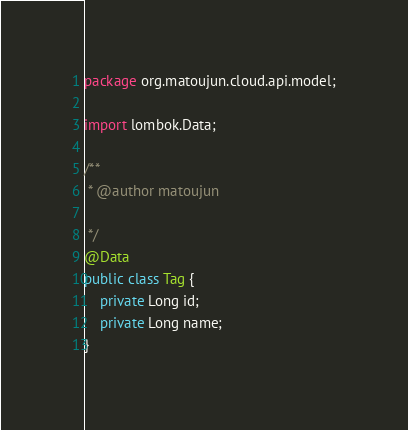<code> <loc_0><loc_0><loc_500><loc_500><_Java_>package org.matoujun.cloud.api.model;

import lombok.Data;

/**
 * @author matoujun

 */
@Data
public class Tag {
    private Long id;
    private Long name;
}
</code> 